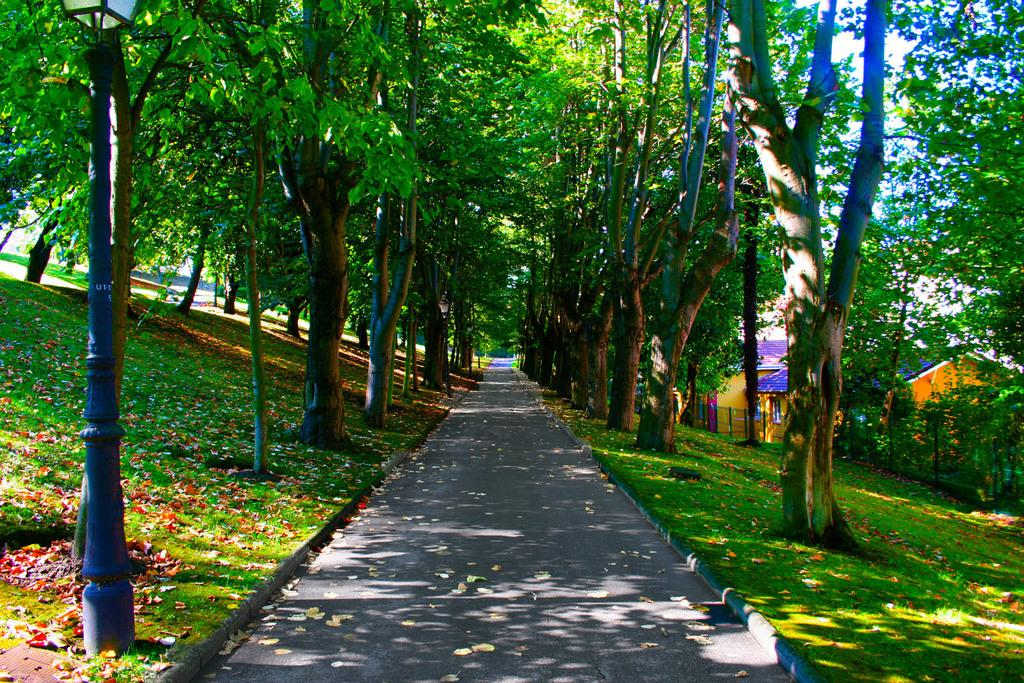What is present on the road in the image? There are leaves on the road in the image. What type of vegetation can be seen in the image? There is grass visible in the image, and there are also trees. What structure is present in the image that might provide illumination? There is a pole with a light in the image. What type of barrier is present in the image? There is a fence in the image. What type of buildings can be seen in the image? There are houses in the image. What is visible in the background of the image? The sky is visible in the background of the image. Can you tell me how many pies are being served by the maid in the image? There is no maid or pie present in the image. What type of hen can be seen interacting with the trees in the image? There is no hen present in the image; only leaves, grass, trees, a pole with a light, a fence, houses, and the sky are visible. 